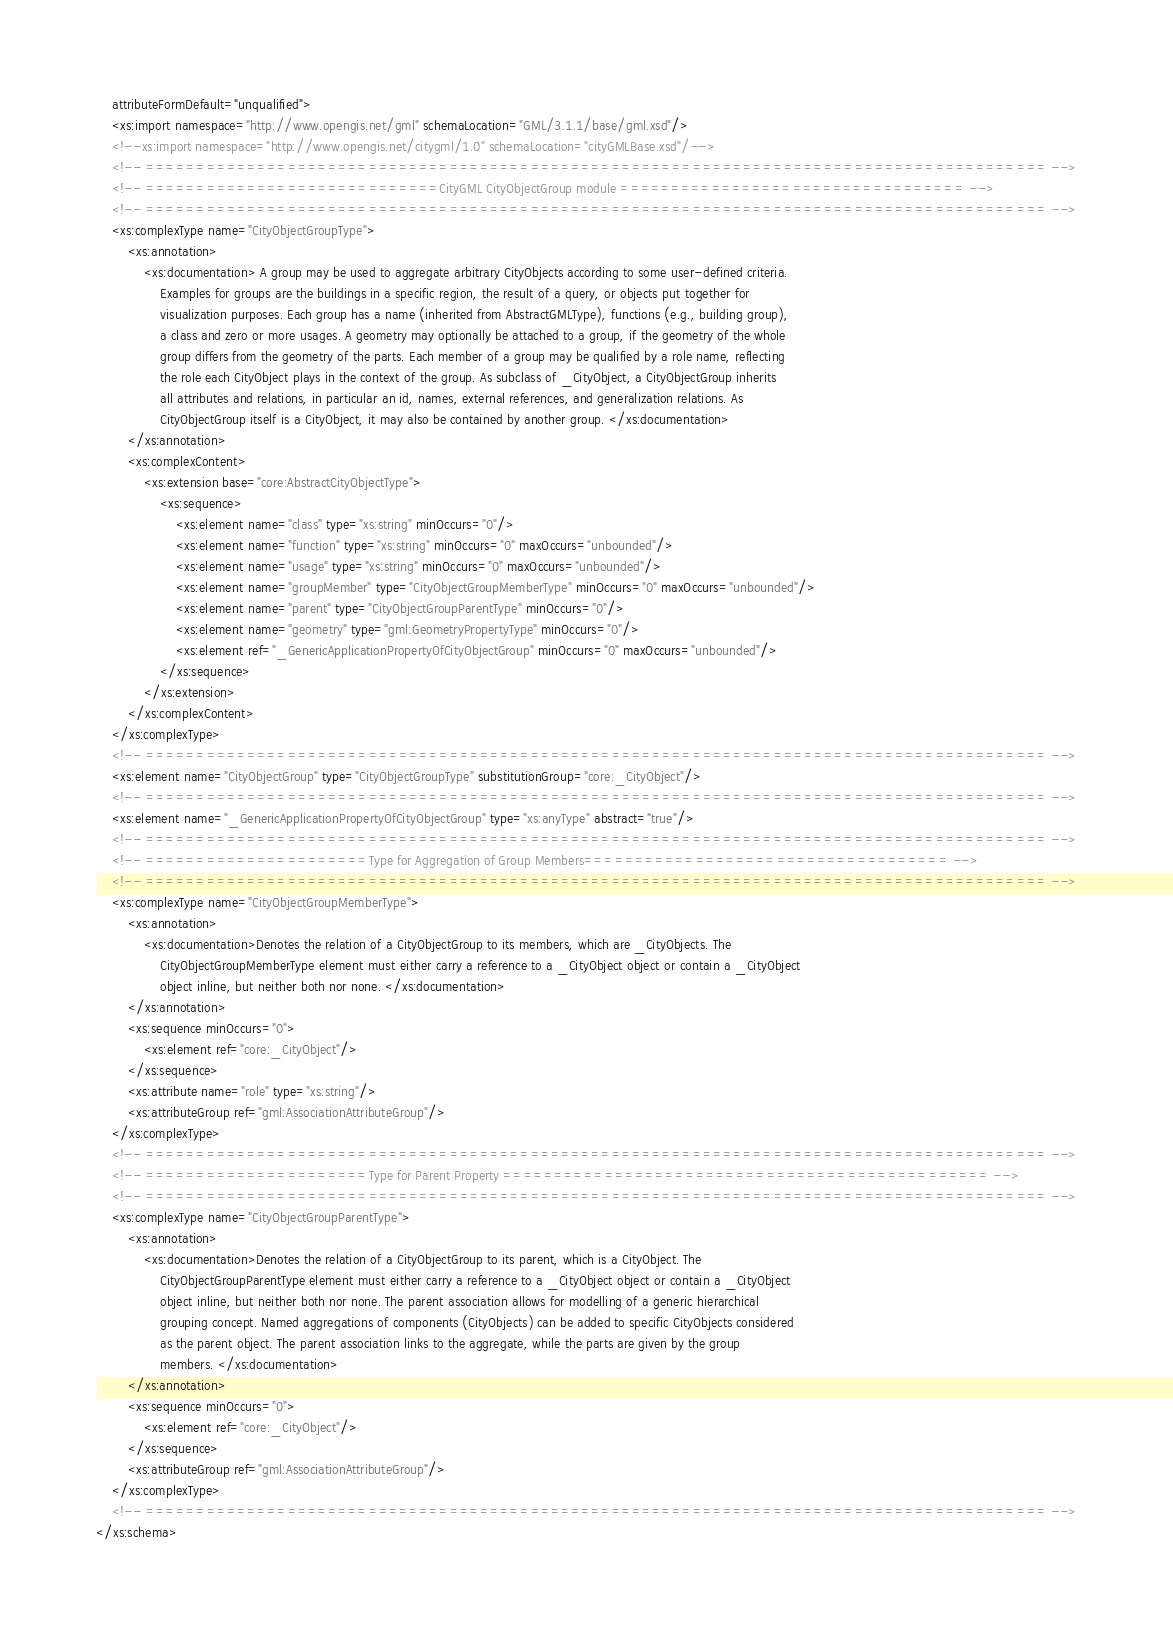<code> <loc_0><loc_0><loc_500><loc_500><_XML_>    attributeFormDefault="unqualified">
    <xs:import namespace="http://www.opengis.net/gml" schemaLocation="GML/3.1.1/base/gml.xsd"/>
    <!--xs:import namespace="http://www.opengis.net/citygml/1.0" schemaLocation="cityGMLBase.xsd"/-->
    <!-- ========================================================================================= -->
    <!-- =============================CityGML CityObjectGroup module ================================== -->
    <!-- ========================================================================================= -->
    <xs:complexType name="CityObjectGroupType">
        <xs:annotation>
            <xs:documentation> A group may be used to aggregate arbitrary CityObjects according to some user-defined criteria.
                Examples for groups are the buildings in a specific region, the result of a query, or objects put together for
                visualization purposes. Each group has a name (inherited from AbstractGMLType), functions (e.g., building group),
                a class and zero or more usages. A geometry may optionally be attached to a group, if the geometry of the whole
                group differs from the geometry of the parts. Each member of a group may be qualified by a role name, reflecting
                the role each CityObject plays in the context of the group. As subclass of _CityObject, a CityObjectGroup inherits
                all attributes and relations, in particular an id, names, external references, and generalization relations. As
                CityObjectGroup itself is a CityObject, it may also be contained by another group. </xs:documentation>
        </xs:annotation>
        <xs:complexContent>
            <xs:extension base="core:AbstractCityObjectType">
                <xs:sequence>
                    <xs:element name="class" type="xs:string" minOccurs="0"/>
                    <xs:element name="function" type="xs:string" minOccurs="0" maxOccurs="unbounded"/>
                    <xs:element name="usage" type="xs:string" minOccurs="0" maxOccurs="unbounded"/>
                    <xs:element name="groupMember" type="CityObjectGroupMemberType" minOccurs="0" maxOccurs="unbounded"/>
                    <xs:element name="parent" type="CityObjectGroupParentType" minOccurs="0"/>
                    <xs:element name="geometry" type="gml:GeometryPropertyType" minOccurs="0"/>
                    <xs:element ref="_GenericApplicationPropertyOfCityObjectGroup" minOccurs="0" maxOccurs="unbounded"/>
                </xs:sequence>
            </xs:extension>
        </xs:complexContent>
    </xs:complexType>
    <!-- ========================================================================================= -->
    <xs:element name="CityObjectGroup" type="CityObjectGroupType" substitutionGroup="core:_CityObject"/>
    <!-- ========================================================================================= -->
    <xs:element name="_GenericApplicationPropertyOfCityObjectGroup" type="xs:anyType" abstract="true"/>
    <!-- ========================================================================================= -->
    <!-- ======================Type for Aggregation of Group Members==================================== -->
    <!-- ========================================================================================= -->
    <xs:complexType name="CityObjectGroupMemberType">
        <xs:annotation>
            <xs:documentation>Denotes the relation of a CityObjectGroup to its members, which are _CityObjects. The
                CityObjectGroupMemberType element must either carry a reference to a _CityObject object or contain a _CityObject
                object inline, but neither both nor none. </xs:documentation>
        </xs:annotation>
        <xs:sequence minOccurs="0">
            <xs:element ref="core:_CityObject"/>
        </xs:sequence>
        <xs:attribute name="role" type="xs:string"/>
        <xs:attributeGroup ref="gml:AssociationAttributeGroup"/>
    </xs:complexType>
    <!-- ========================================================================================= -->
    <!-- ======================Type for Parent Property ================================================ -->
    <!-- ========================================================================================= -->
    <xs:complexType name="CityObjectGroupParentType">
        <xs:annotation>
            <xs:documentation>Denotes the relation of a CityObjectGroup to its parent, which is a CityObject. The
                CityObjectGroupParentType element must either carry a reference to a _CityObject object or contain a _CityObject
                object inline, but neither both nor none. The parent association allows for modelling of a generic hierarchical
                grouping concept. Named aggregations of components (CityObjects) can be added to specific CityObjects considered
                as the parent object. The parent association links to the aggregate, while the parts are given by the group
                members. </xs:documentation>
        </xs:annotation>
        <xs:sequence minOccurs="0">
            <xs:element ref="core:_CityObject"/>
        </xs:sequence>
        <xs:attributeGroup ref="gml:AssociationAttributeGroup"/>
    </xs:complexType>
    <!-- ========================================================================================= -->
</xs:schema>
</code> 